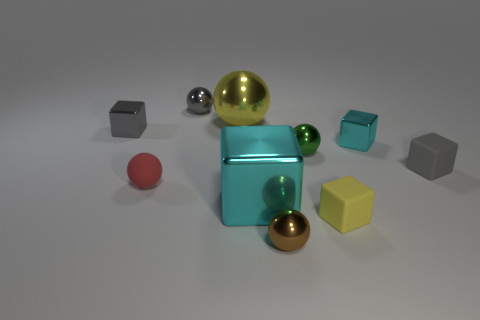The object that is the same color as the large block is what shape?
Your answer should be compact. Cube. There is a rubber object that is left of the small brown ball; is its color the same as the large metallic cube?
Give a very brief answer. No. What number of blocks are the same size as the gray sphere?
Offer a very short reply. 4. What is the shape of the large cyan thing that is the same material as the tiny brown thing?
Provide a succinct answer. Cube. Is there a large object of the same color as the big shiny block?
Provide a short and direct response. No. What is the material of the brown thing?
Make the answer very short. Metal. What number of objects are gray metallic balls or tiny cyan shiny spheres?
Your response must be concise. 1. There is a yellow thing on the left side of the big cube; how big is it?
Offer a terse response. Large. How many other things are there of the same material as the small red thing?
Make the answer very short. 2. There is a metallic object behind the big yellow object; is there a tiny red sphere right of it?
Provide a succinct answer. No. 